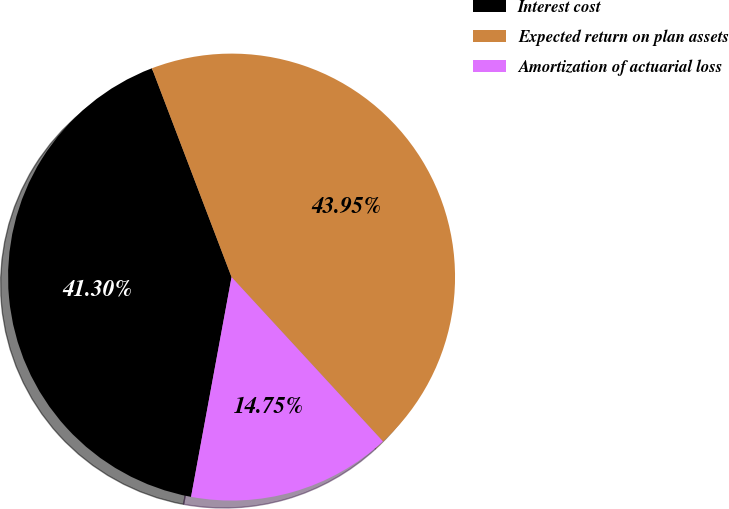Convert chart to OTSL. <chart><loc_0><loc_0><loc_500><loc_500><pie_chart><fcel>Interest cost<fcel>Expected return on plan assets<fcel>Amortization of actuarial loss<nl><fcel>41.3%<fcel>43.95%<fcel>14.75%<nl></chart> 